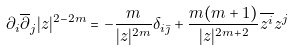<formula> <loc_0><loc_0><loc_500><loc_500>\partial _ { i } \overline { \partial } _ { j } | z | ^ { 2 - 2 m } = - \frac { m } { | z | ^ { 2 m } } \delta _ { i \bar { \jmath } } + \frac { m ( m + 1 ) } { | z | ^ { 2 m + 2 } } \overline { z ^ { i } } z ^ { j }</formula> 